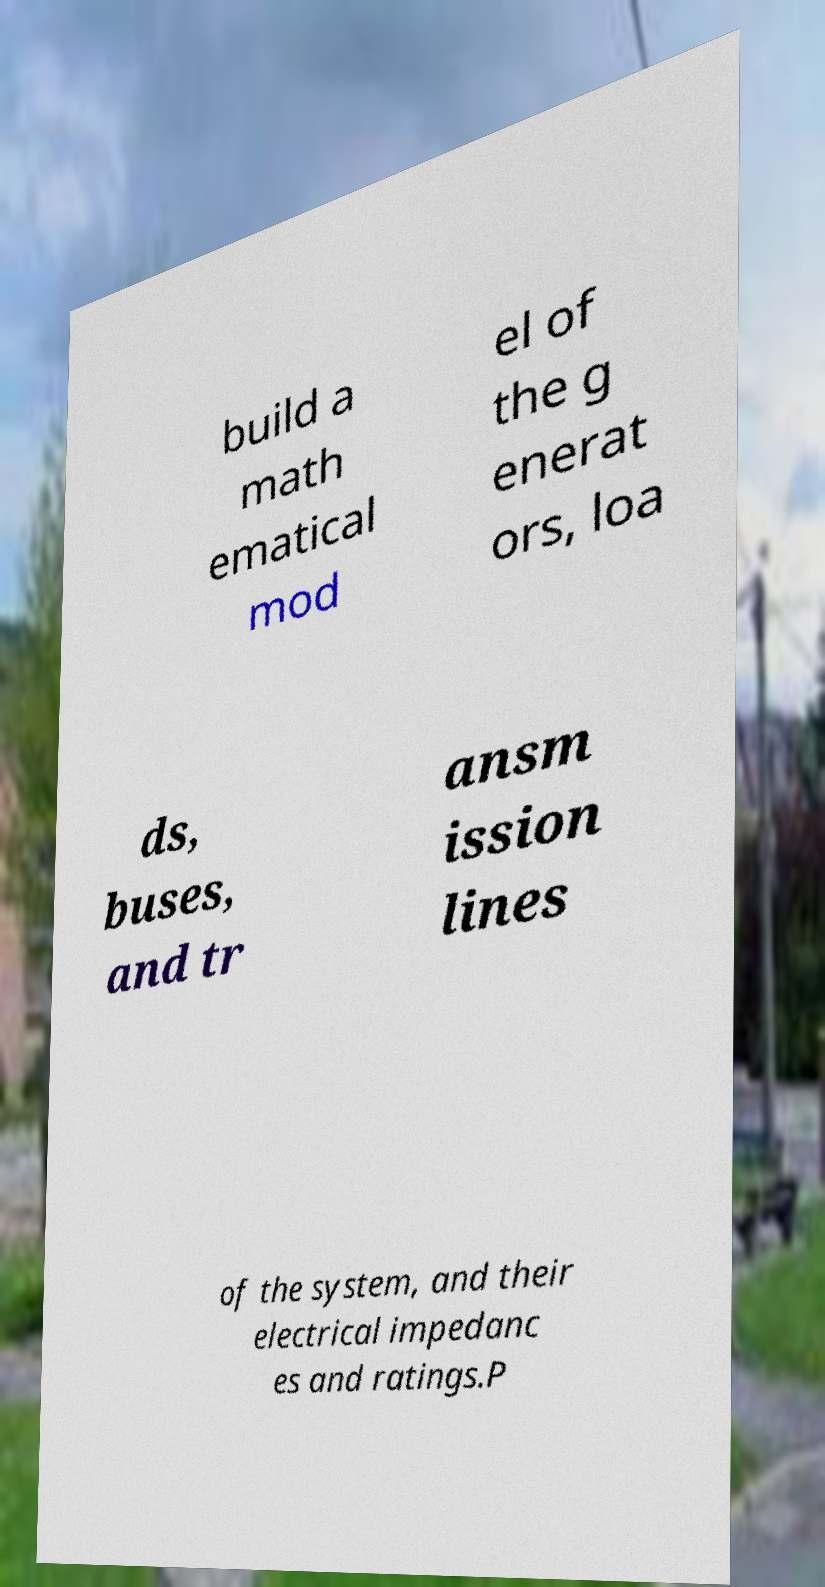For documentation purposes, I need the text within this image transcribed. Could you provide that? build a math ematical mod el of the g enerat ors, loa ds, buses, and tr ansm ission lines of the system, and their electrical impedanc es and ratings.P 